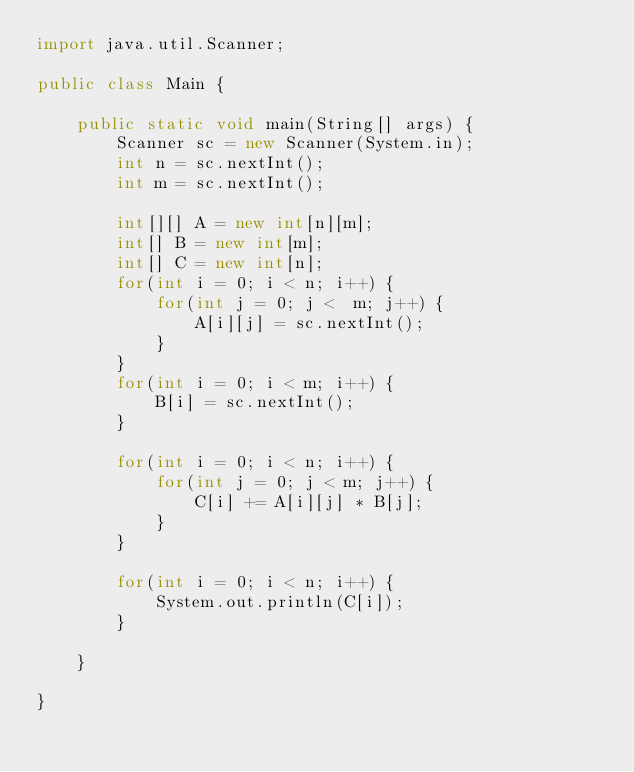Convert code to text. <code><loc_0><loc_0><loc_500><loc_500><_Java_>import java.util.Scanner;

public class Main {

	public static void main(String[] args) {
		Scanner sc = new Scanner(System.in);
        int n = sc.nextInt();
        int m = sc.nextInt();
         
        int[][] A = new int[n][m];
        int[] B = new int[m];
        int[] C = new int[n];
        for(int i = 0; i < n; i++) {
            for(int j = 0; j <  m; j++) {
                A[i][j] = sc.nextInt();
            }
        }
        for(int i = 0; i < m; i++) {
            B[i] = sc.nextInt();
        }
         
        for(int i = 0; i < n; i++) {
            for(int j = 0; j < m; j++) {
                C[i] += A[i][j] * B[j];
            }
        }
         
        for(int i = 0; i < n; i++) {
            System.out.println(C[i]);
        }

	}

}
</code> 